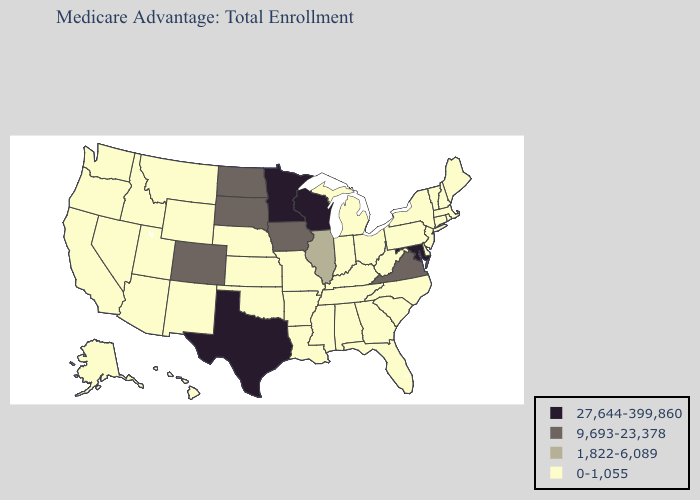Does Maryland have the lowest value in the South?
Be succinct. No. What is the lowest value in the USA?
Concise answer only. 0-1,055. Does Texas have the lowest value in the South?
Short answer required. No. How many symbols are there in the legend?
Give a very brief answer. 4. What is the lowest value in the USA?
Concise answer only. 0-1,055. What is the highest value in the USA?
Concise answer only. 27,644-399,860. Name the states that have a value in the range 1,822-6,089?
Concise answer only. Illinois. Which states hav the highest value in the South?
Write a very short answer. Maryland, Texas. What is the lowest value in the USA?
Short answer required. 0-1,055. Name the states that have a value in the range 1,822-6,089?
Quick response, please. Illinois. What is the value of Indiana?
Short answer required. 0-1,055. Does Iowa have the lowest value in the USA?
Keep it brief. No. Is the legend a continuous bar?
Quick response, please. No. What is the lowest value in the USA?
Quick response, please. 0-1,055. Name the states that have a value in the range 1,822-6,089?
Give a very brief answer. Illinois. 